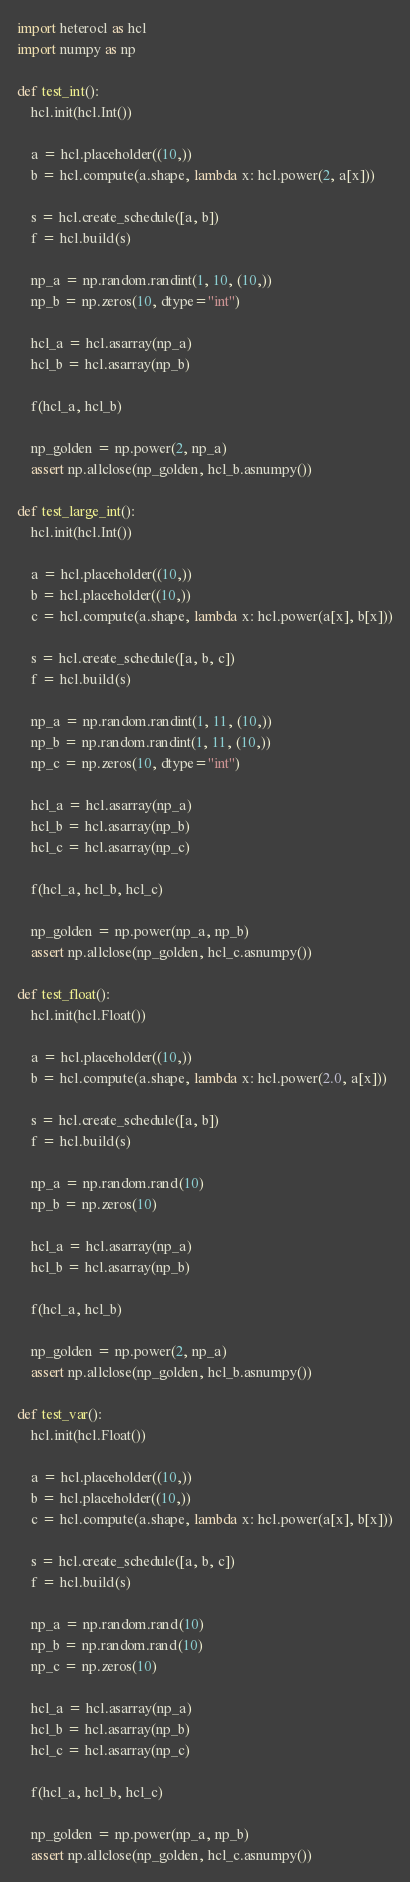Convert code to text. <code><loc_0><loc_0><loc_500><loc_500><_Python_>import heterocl as hcl
import numpy as np

def test_int():
    hcl.init(hcl.Int())

    a = hcl.placeholder((10,))
    b = hcl.compute(a.shape, lambda x: hcl.power(2, a[x]))

    s = hcl.create_schedule([a, b])
    f = hcl.build(s)

    np_a = np.random.randint(1, 10, (10,))
    np_b = np.zeros(10, dtype="int")

    hcl_a = hcl.asarray(np_a)
    hcl_b = hcl.asarray(np_b)

    f(hcl_a, hcl_b)

    np_golden = np.power(2, np_a)
    assert np.allclose(np_golden, hcl_b.asnumpy())

def test_large_int():
    hcl.init(hcl.Int())

    a = hcl.placeholder((10,))
    b = hcl.placeholder((10,))
    c = hcl.compute(a.shape, lambda x: hcl.power(a[x], b[x]))

    s = hcl.create_schedule([a, b, c])
    f = hcl.build(s)

    np_a = np.random.randint(1, 11, (10,))
    np_b = np.random.randint(1, 11, (10,))
    np_c = np.zeros(10, dtype="int")

    hcl_a = hcl.asarray(np_a)
    hcl_b = hcl.asarray(np_b)
    hcl_c = hcl.asarray(np_c)

    f(hcl_a, hcl_b, hcl_c)

    np_golden = np.power(np_a, np_b)
    assert np.allclose(np_golden, hcl_c.asnumpy())

def test_float():
    hcl.init(hcl.Float())

    a = hcl.placeholder((10,))
    b = hcl.compute(a.shape, lambda x: hcl.power(2.0, a[x]))

    s = hcl.create_schedule([a, b])
    f = hcl.build(s)

    np_a = np.random.rand(10)
    np_b = np.zeros(10)

    hcl_a = hcl.asarray(np_a)
    hcl_b = hcl.asarray(np_b)

    f(hcl_a, hcl_b)

    np_golden = np.power(2, np_a)
    assert np.allclose(np_golden, hcl_b.asnumpy())

def test_var():
    hcl.init(hcl.Float())

    a = hcl.placeholder((10,))
    b = hcl.placeholder((10,))
    c = hcl.compute(a.shape, lambda x: hcl.power(a[x], b[x]))

    s = hcl.create_schedule([a, b, c])
    f = hcl.build(s)

    np_a = np.random.rand(10)
    np_b = np.random.rand(10)
    np_c = np.zeros(10)

    hcl_a = hcl.asarray(np_a)
    hcl_b = hcl.asarray(np_b)
    hcl_c = hcl.asarray(np_c)

    f(hcl_a, hcl_b, hcl_c)

    np_golden = np.power(np_a, np_b)
    assert np.allclose(np_golden, hcl_c.asnumpy())
</code> 